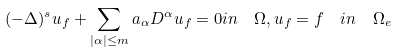Convert formula to latex. <formula><loc_0><loc_0><loc_500><loc_500>( - \Delta ) ^ { s } u _ { f } + \sum _ { | \alpha | \leq m } a _ { \alpha } D ^ { \alpha } u _ { f } & = 0 i n \quad \Omega , u _ { f } = f \quad i n \quad \Omega _ { e }</formula> 